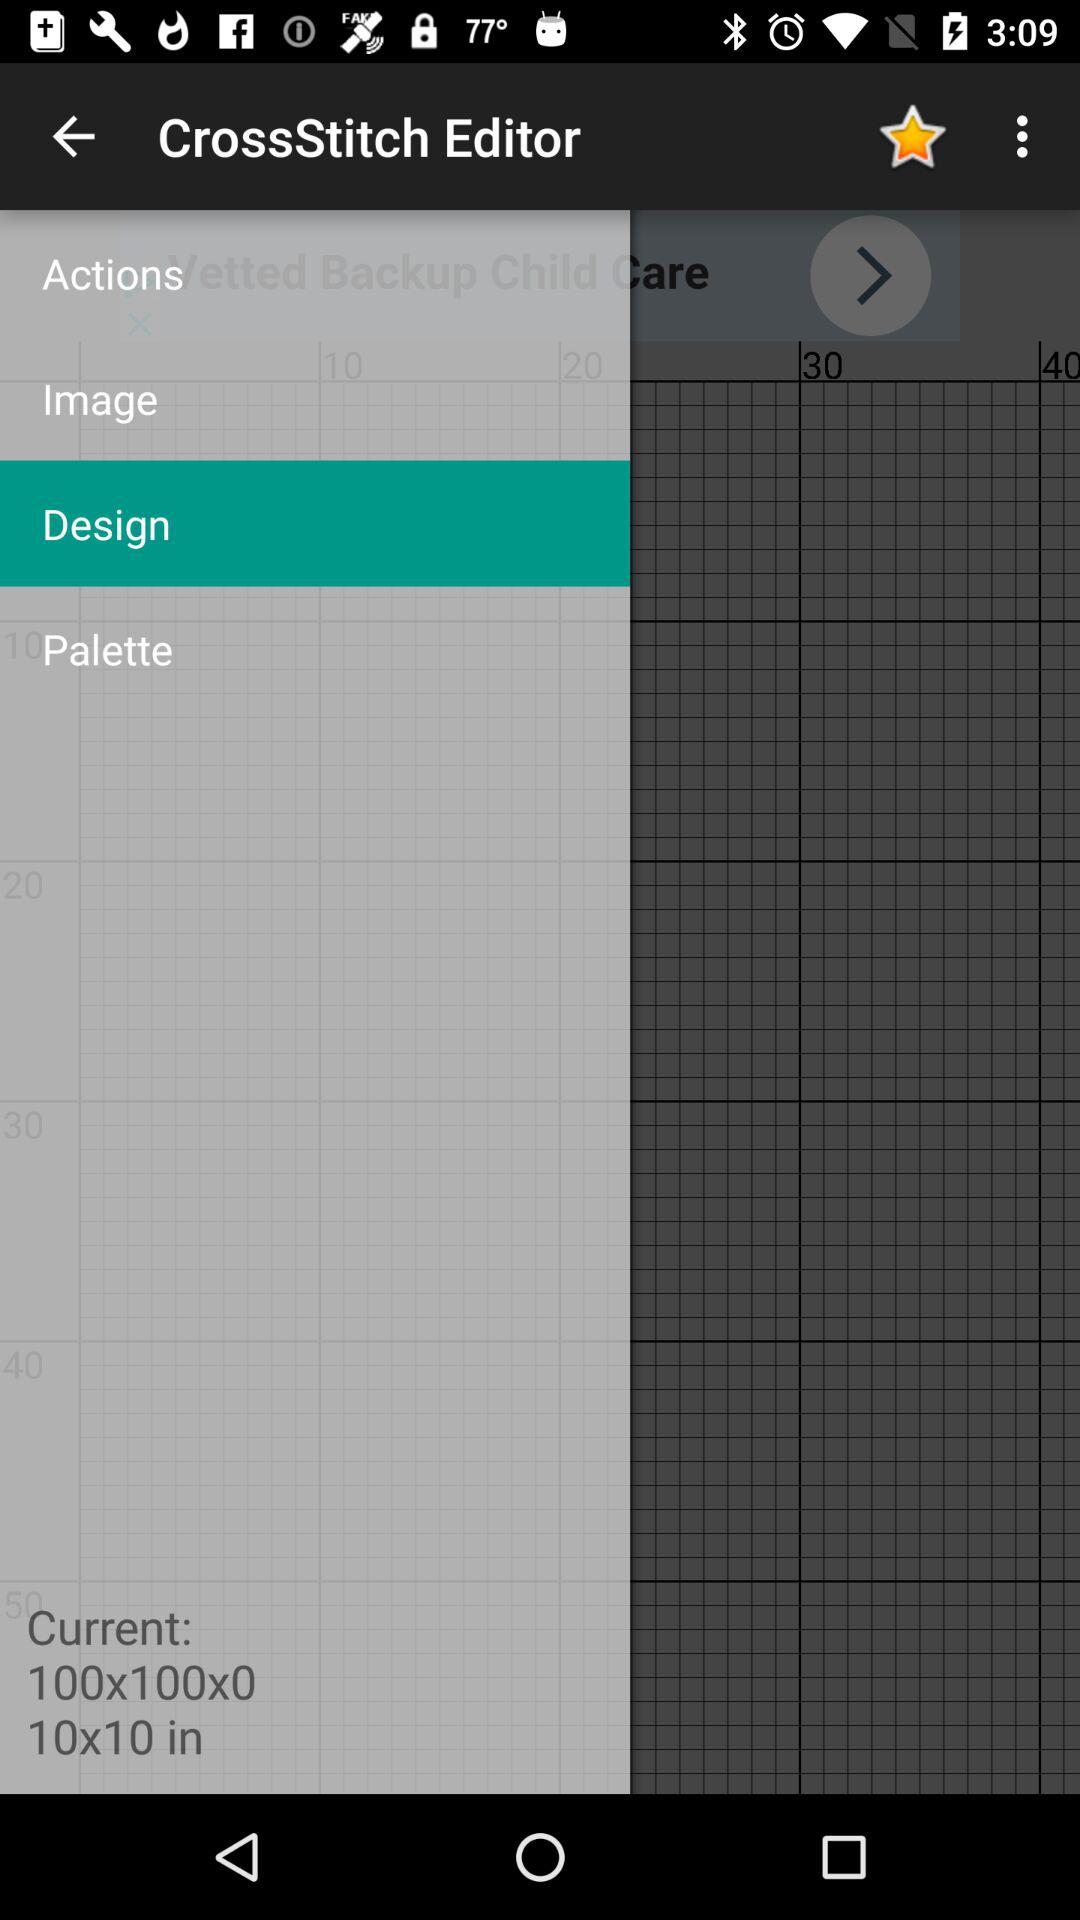What are the current dimensions? The current dimensions are 100x100x0 and 10x10 inches. 